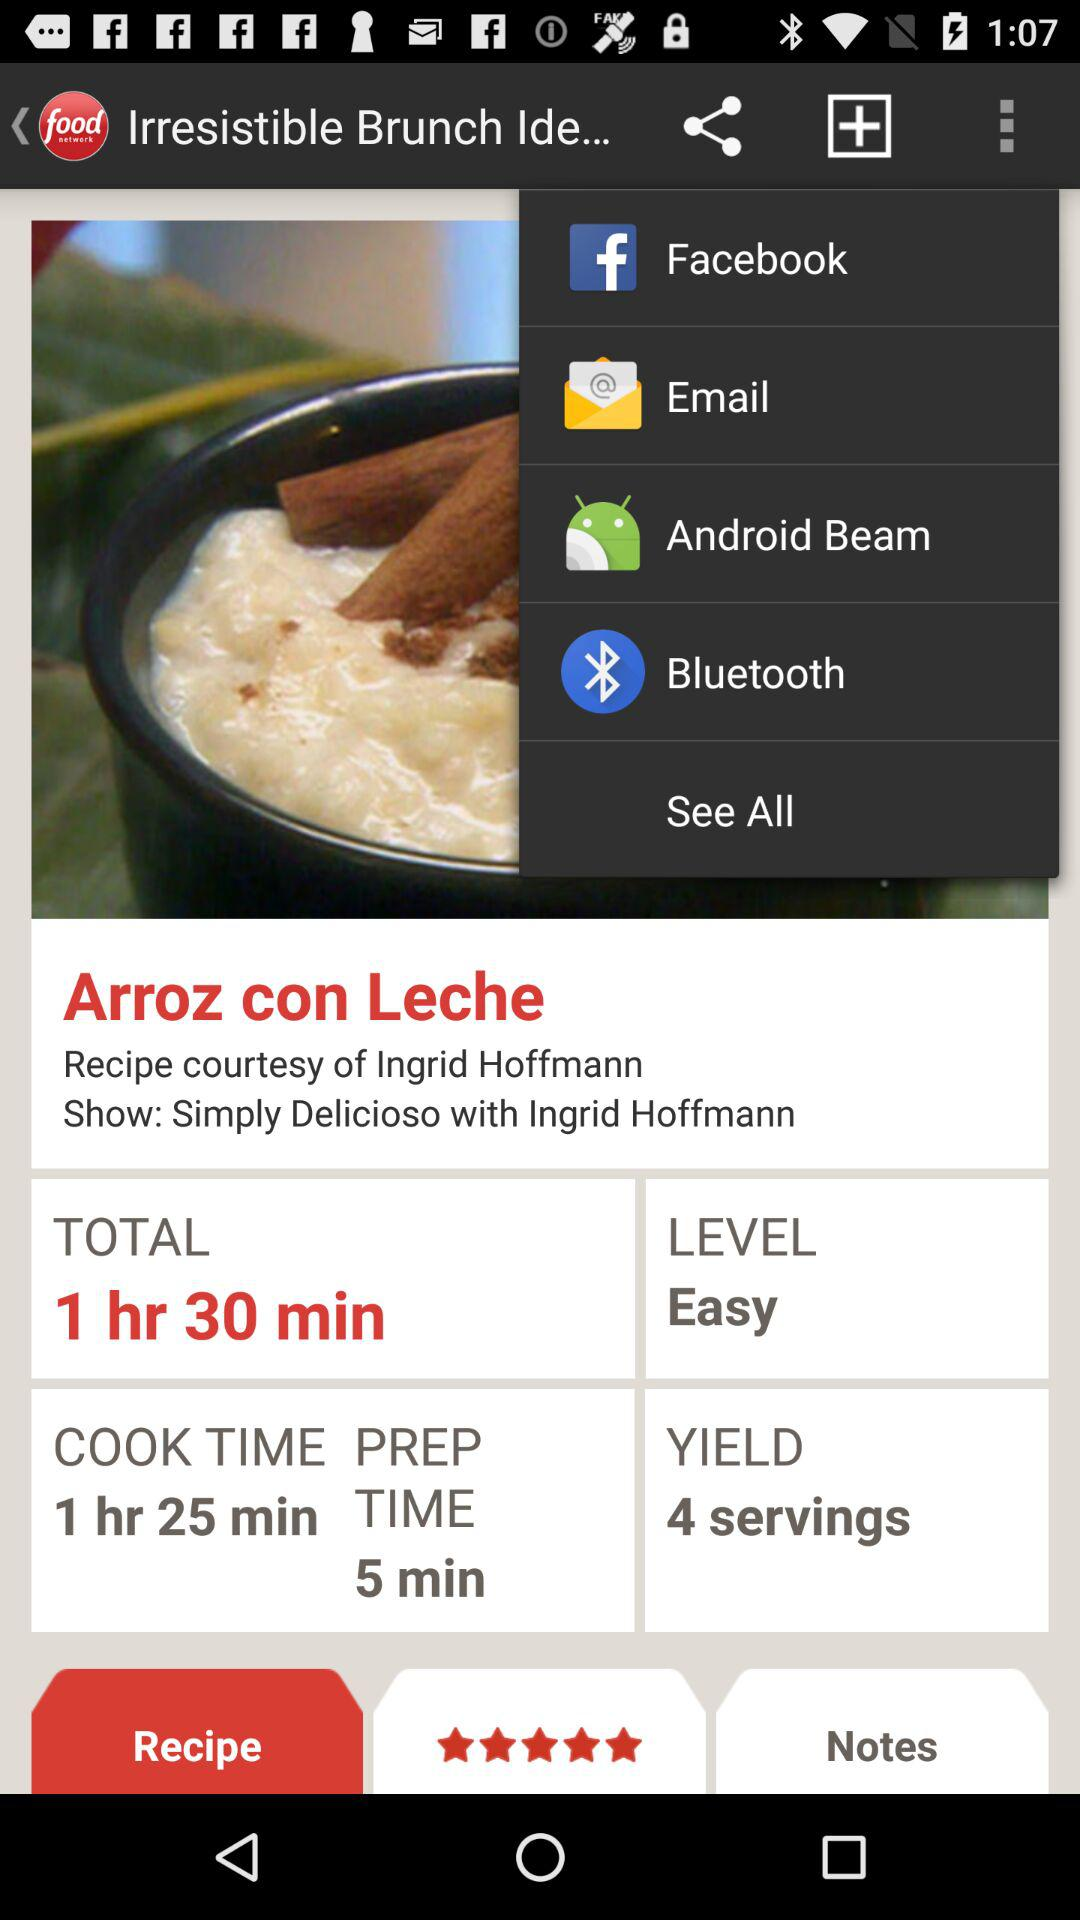What is the total preparation time? The total preparation time is 5 minutes. 